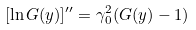<formula> <loc_0><loc_0><loc_500><loc_500>[ \ln G ( y ) ] ^ { \prime \prime } = \gamma _ { 0 } ^ { 2 } ( G ( y ) - 1 )</formula> 